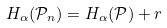Convert formula to latex. <formula><loc_0><loc_0><loc_500><loc_500>H _ { \alpha } ( \mathcal { P } _ { n } ) = H _ { \alpha } ( \mathcal { P } ) + r</formula> 